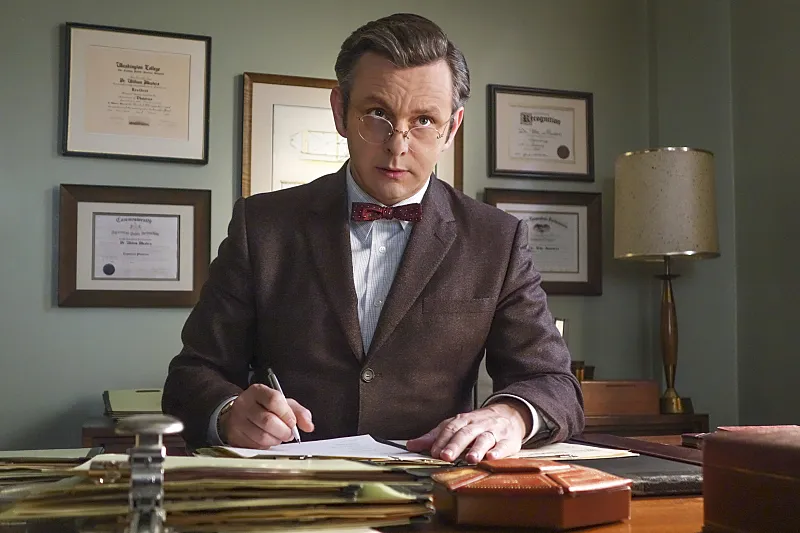What details in this image suggest the historical period of the scene? The historical setting is subtly conveyed through the style of the clothing, particularly the brown suit and red bowtie, and the classic design of the office furniture and decor. The items on the desk, such as the vintage lamp, pen, and paper, along with the traditional frames and certificates on the wall, suggest a mid-20th century setting, aligning with the era depicted in the television series. 